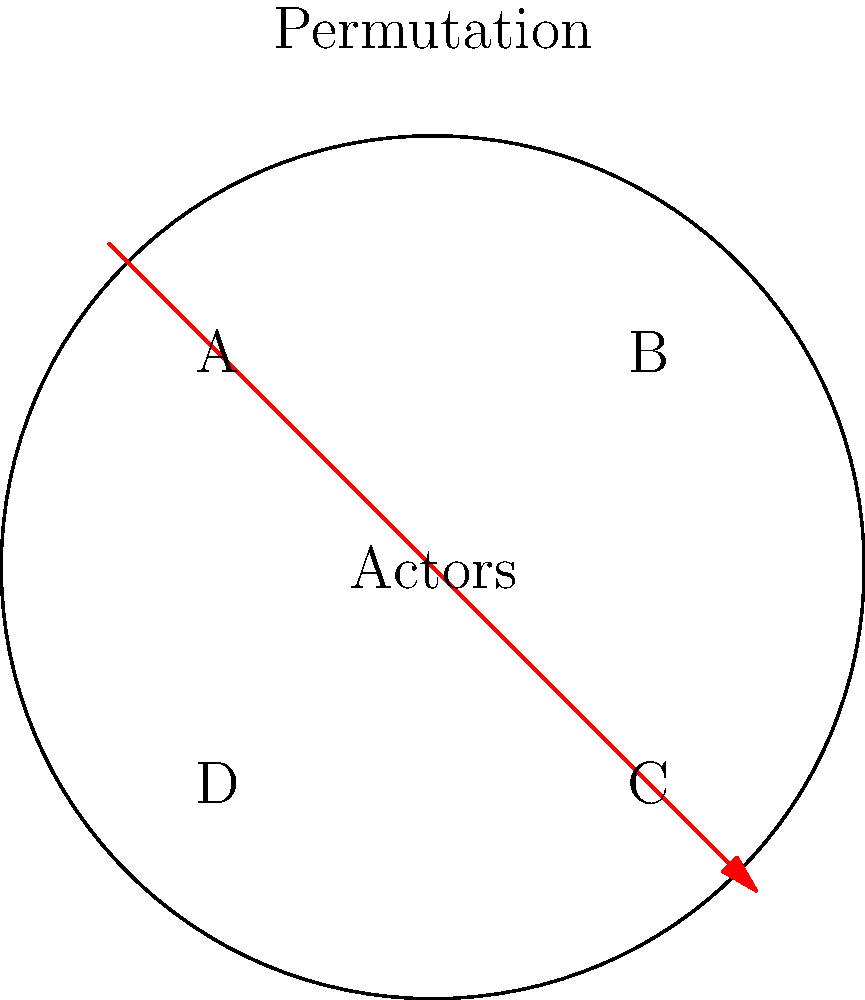In Denys Arcand's film "The Decline of the American Empire" (1986), four main actors form an ensemble cast. If we represent their positions in the film's promotional poster as A, B, C, and D, and consider all possible permutations of these actors, how many unique arrangements are possible that leave at least one actor in their original position? To solve this problem, we need to use the concept of derangements in permutation theory. A derangement is a permutation where no element appears in its original position.

Step 1: Calculate the total number of permutations.
Total permutations = 4! = 4 × 3 × 2 × 1 = 24

Step 2: Calculate the number of derangements.
The formula for derangements of n elements is:
$$!n = n! \sum_{k=0}^n \frac{(-1)^k}{k!}$$

For n = 4:
$$!4 = 4! (1 - \frac{1}{1!} + \frac{1}{2!} - \frac{1}{3!} + \frac{1}{4!}) = 24 (1 - 1 + \frac{1}{2} - \frac{1}{6} + \frac{1}{24}) = 9$$

Step 3: Calculate the number of permutations with at least one actor in their original position.
This is the total number of permutations minus the number of derangements.
Permutations with at least one fixed point = 24 - 9 = 15

Therefore, there are 15 unique arrangements that leave at least one actor in their original position.
Answer: 15 arrangements 